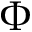<formula> <loc_0><loc_0><loc_500><loc_500>\Phi</formula> 